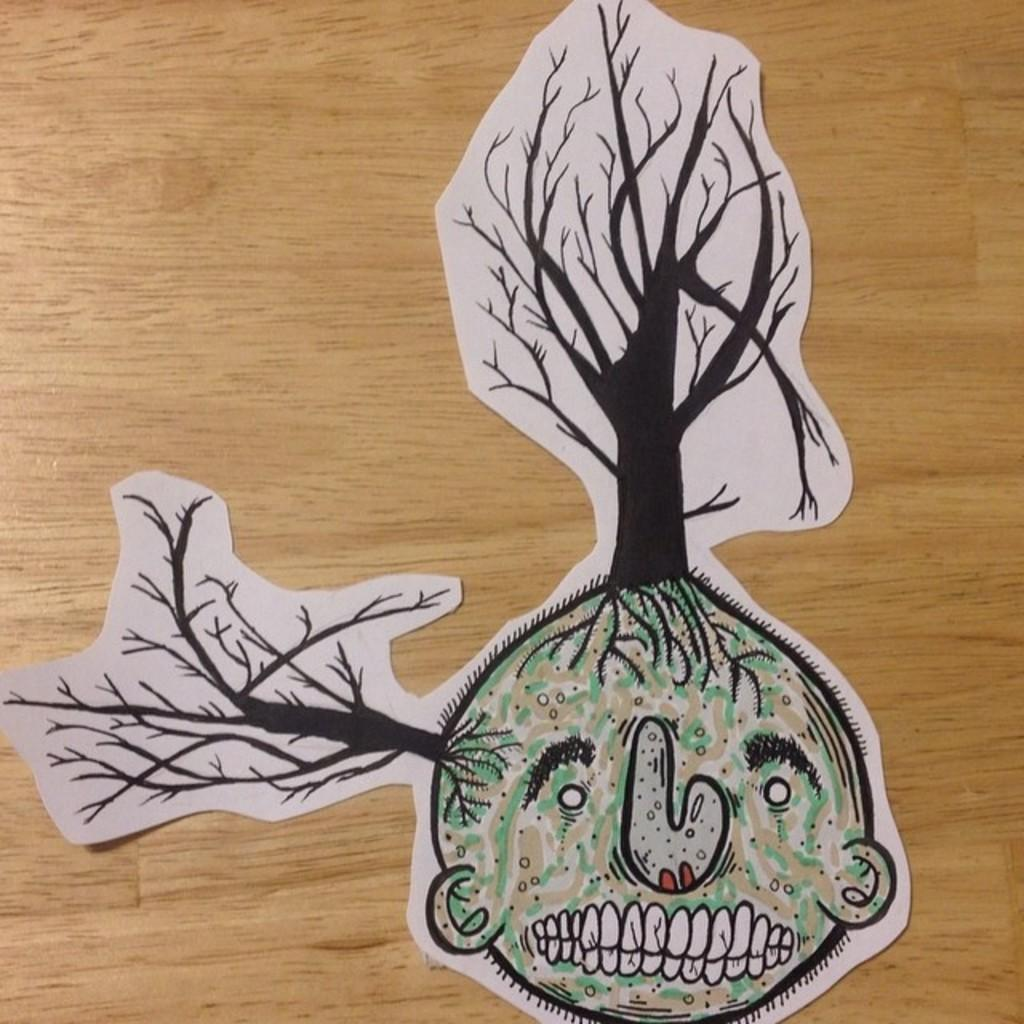What is the main subject on the wooden surface in the image? There is a paper craft on a wooden surface. What type of natural environment can be seen in the image? There are trees visible in the image. Can you describe the face present in the image? Yes, there is a face present in the image. What type of shoe can be seen in the image? There is no shoe present in the image. What type of building can be seen in the image? There is no building present in the image. Is there any dirt visible in the image? There is no dirt visible in the image. 